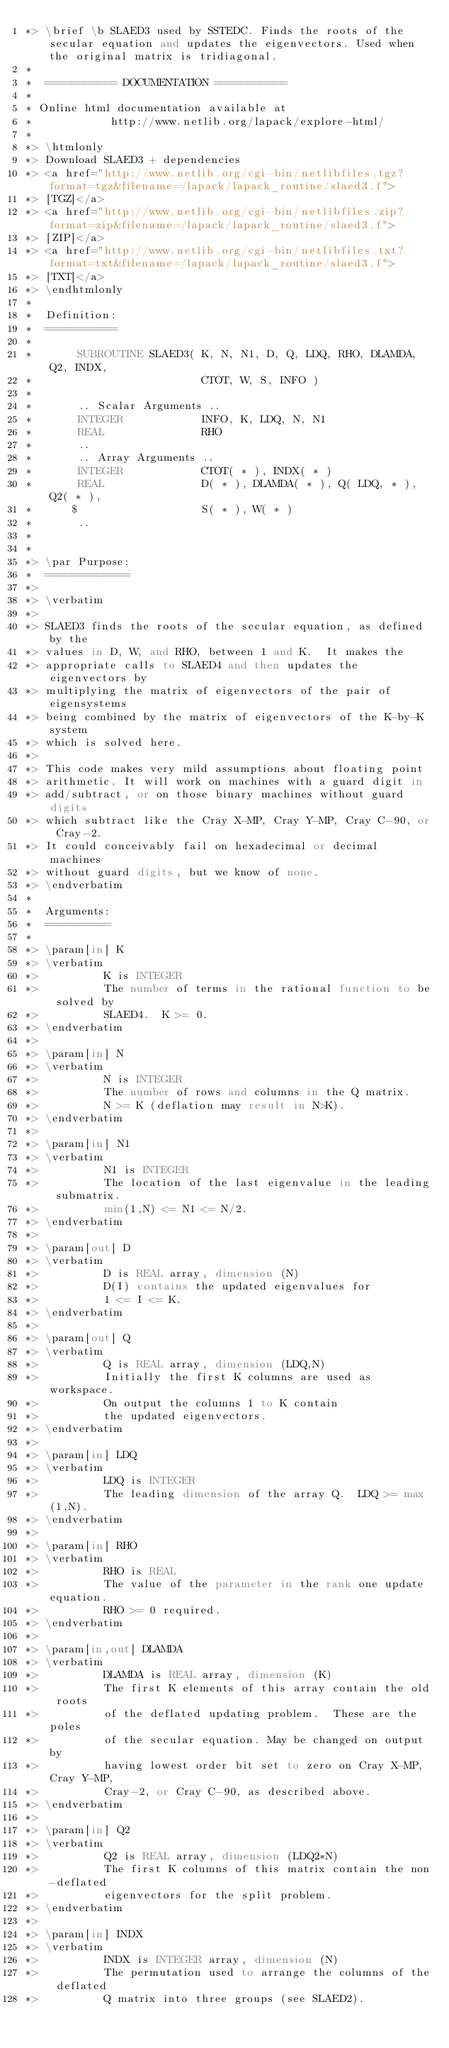<code> <loc_0><loc_0><loc_500><loc_500><_FORTRAN_>*> \brief \b SLAED3 used by SSTEDC. Finds the roots of the secular equation and updates the eigenvectors. Used when the original matrix is tridiagonal.
*
*  =========== DOCUMENTATION ===========
*
* Online html documentation available at
*            http://www.netlib.org/lapack/explore-html/
*
*> \htmlonly
*> Download SLAED3 + dependencies
*> <a href="http://www.netlib.org/cgi-bin/netlibfiles.tgz?format=tgz&filename=/lapack/lapack_routine/slaed3.f">
*> [TGZ]</a>
*> <a href="http://www.netlib.org/cgi-bin/netlibfiles.zip?format=zip&filename=/lapack/lapack_routine/slaed3.f">
*> [ZIP]</a>
*> <a href="http://www.netlib.org/cgi-bin/netlibfiles.txt?format=txt&filename=/lapack/lapack_routine/slaed3.f">
*> [TXT]</a>
*> \endhtmlonly
*
*  Definition:
*  ===========
*
*       SUBROUTINE SLAED3( K, N, N1, D, Q, LDQ, RHO, DLAMDA, Q2, INDX,
*                          CTOT, W, S, INFO )
*
*       .. Scalar Arguments ..
*       INTEGER            INFO, K, LDQ, N, N1
*       REAL               RHO
*       ..
*       .. Array Arguments ..
*       INTEGER            CTOT( * ), INDX( * )
*       REAL               D( * ), DLAMDA( * ), Q( LDQ, * ), Q2( * ),
*      $                   S( * ), W( * )
*       ..
*
*
*> \par Purpose:
*  =============
*>
*> \verbatim
*>
*> SLAED3 finds the roots of the secular equation, as defined by the
*> values in D, W, and RHO, between 1 and K.  It makes the
*> appropriate calls to SLAED4 and then updates the eigenvectors by
*> multiplying the matrix of eigenvectors of the pair of eigensystems
*> being combined by the matrix of eigenvectors of the K-by-K system
*> which is solved here.
*>
*> This code makes very mild assumptions about floating point
*> arithmetic. It will work on machines with a guard digit in
*> add/subtract, or on those binary machines without guard digits
*> which subtract like the Cray X-MP, Cray Y-MP, Cray C-90, or Cray-2.
*> It could conceivably fail on hexadecimal or decimal machines
*> without guard digits, but we know of none.
*> \endverbatim
*
*  Arguments:
*  ==========
*
*> \param[in] K
*> \verbatim
*>          K is INTEGER
*>          The number of terms in the rational function to be solved by
*>          SLAED4.  K >= 0.
*> \endverbatim
*>
*> \param[in] N
*> \verbatim
*>          N is INTEGER
*>          The number of rows and columns in the Q matrix.
*>          N >= K (deflation may result in N>K).
*> \endverbatim
*>
*> \param[in] N1
*> \verbatim
*>          N1 is INTEGER
*>          The location of the last eigenvalue in the leading submatrix.
*>          min(1,N) <= N1 <= N/2.
*> \endverbatim
*>
*> \param[out] D
*> \verbatim
*>          D is REAL array, dimension (N)
*>          D(I) contains the updated eigenvalues for
*>          1 <= I <= K.
*> \endverbatim
*>
*> \param[out] Q
*> \verbatim
*>          Q is REAL array, dimension (LDQ,N)
*>          Initially the first K columns are used as workspace.
*>          On output the columns 1 to K contain
*>          the updated eigenvectors.
*> \endverbatim
*>
*> \param[in] LDQ
*> \verbatim
*>          LDQ is INTEGER
*>          The leading dimension of the array Q.  LDQ >= max(1,N).
*> \endverbatim
*>
*> \param[in] RHO
*> \verbatim
*>          RHO is REAL
*>          The value of the parameter in the rank one update equation.
*>          RHO >= 0 required.
*> \endverbatim
*>
*> \param[in,out] DLAMDA
*> \verbatim
*>          DLAMDA is REAL array, dimension (K)
*>          The first K elements of this array contain the old roots
*>          of the deflated updating problem.  These are the poles
*>          of the secular equation. May be changed on output by
*>          having lowest order bit set to zero on Cray X-MP, Cray Y-MP,
*>          Cray-2, or Cray C-90, as described above.
*> \endverbatim
*>
*> \param[in] Q2
*> \verbatim
*>          Q2 is REAL array, dimension (LDQ2*N)
*>          The first K columns of this matrix contain the non-deflated
*>          eigenvectors for the split problem.
*> \endverbatim
*>
*> \param[in] INDX
*> \verbatim
*>          INDX is INTEGER array, dimension (N)
*>          The permutation used to arrange the columns of the deflated
*>          Q matrix into three groups (see SLAED2).</code> 